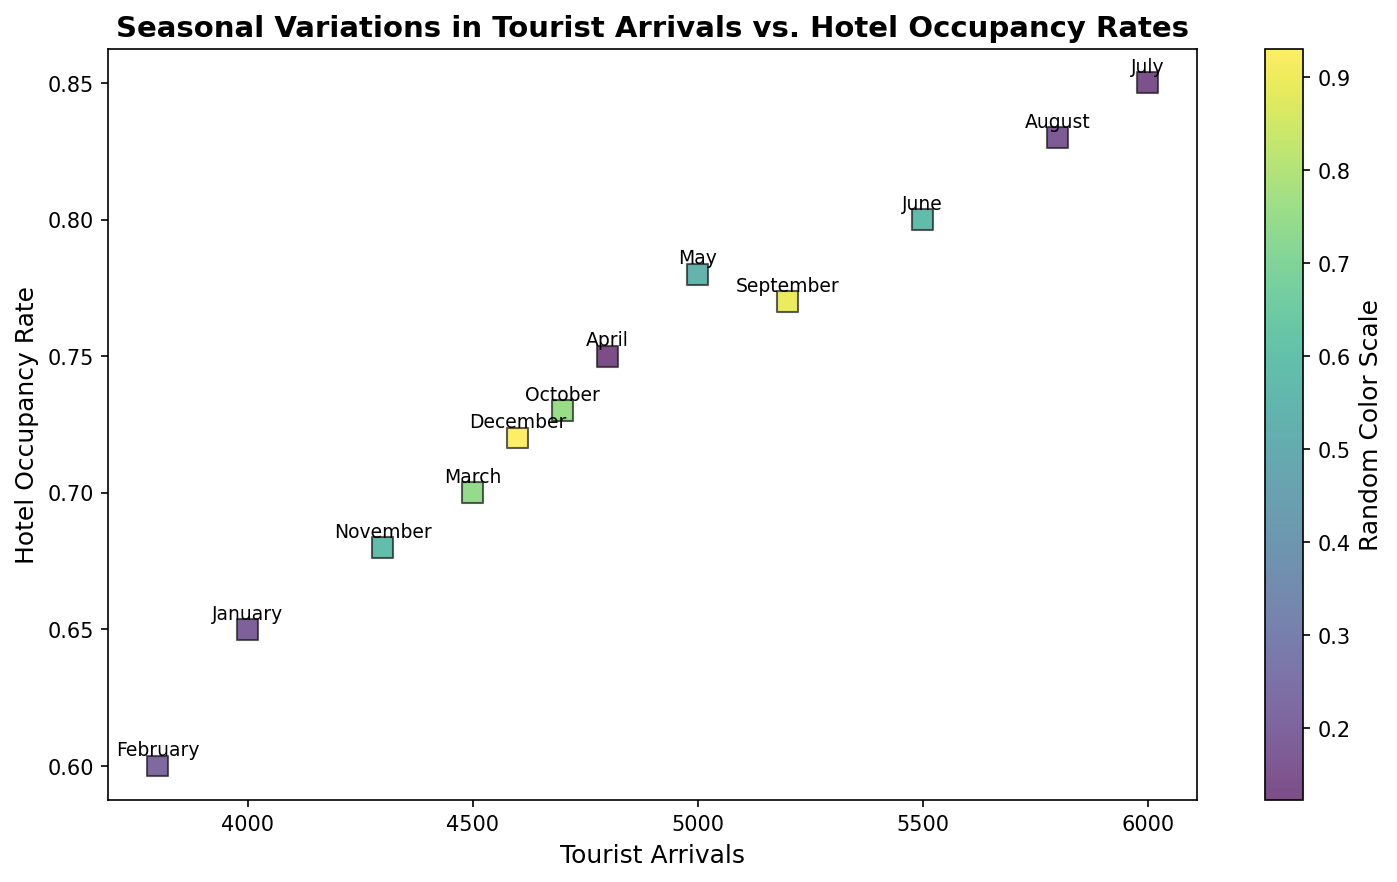What's the month with the highest hotel occupancy rate? The plot clearly shows that July has the highest hotel occupancy rate, represented by the point farthest up on the y-axis.
Answer: July Which month has more tourist arrivals: March or August? According to the scatter plot, August has slightly more tourist arrivals compared to March, as the point for August is further right on the x-axis.
Answer: August What's the average hotel occupancy rate for the first quarter (January to March)? The hotel occupancy rates for January, February, and March are 0.65, 0.60, and 0.70 respectively. Adding them gives 1.95, and dividing by 3 gives an average of 0.65.
Answer: 0.65 Does February have a higher hotel occupancy rate than November? By checking the vertical position of the points labeled "February" and "November", it's clear that February has a lower occupancy rate (0.60) compared to November (0.68).
Answer: No Which month shows the highest tourist arrivals, and what is the corresponding hotel occupancy rate? July has the highest tourist arrivals, with a value of 6000. The corresponding hotel occupancy rate for July is 0.85, according to the scatter plot.
Answer: 6000 and 0.85 What is the difference in hotel occupancy rates between the months with the highest and lowest tourist arrivals? The month with the highest tourist arrivals (July) has an occupancy rate of 0.85, and the month with the lowest tourist arrivals (February) has an occupancy rate of 0.60. The difference is 0.85 - 0.60 = 0.25.
Answer: 0.25 Which has a greater change over the year: Tourist arrivals or hotel occupancy rates? Tourist arrivals range from 3800 to 6000, a difference of 2200. Hotel occupancy rates range from 0.60 to 0.85, a difference of 0.25. The change in tourist arrivals is larger when considering the scale.
Answer: Tourist arrivals What's the trend between tourist arrivals and hotel occupancy rates over the months? Examining the scatter plot, one can observe that as tourist arrivals increase (moving right on the x-axis), the hotel occupancy rate tends to increase as well (moving up on the y-axis). This suggests a positive correlation.
Answer: Positive correlation Compare the hotel occupancy rates in the first half of the year (January to June) with the second half (July to December). Which is higher on average? Average for January to June: (0.65+0.60+0.70+0.75+0.78+0.80)/6 = 0.7133. Average for July to December: (0.85+0.83+0.77+0.73+0.68+0.72)/6 = 0.76. The second half has a higher average hotel occupancy rate.
Answer: Second half Which month has the closest values in tourist arrivals and hotel occupancy rates, considering their respective scales? November has tourist arrivals of 4300 and a hotel occupancy rate of 0.68. Comparatively, both values are relatively lower in scale within the year, making November the closest in terms of their respective scales.
Answer: November 